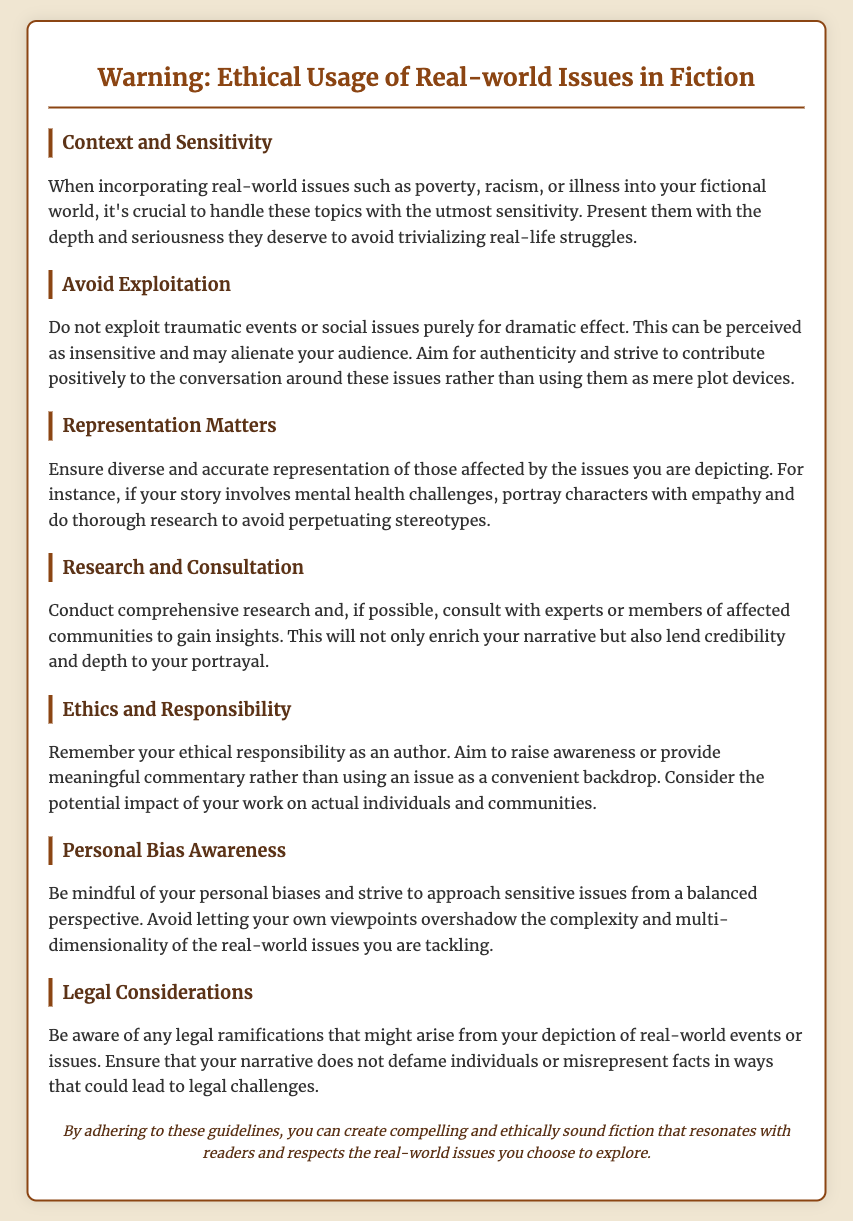What is the title of the document? The title is prominently displayed at the top of the document, summarizing its purpose regarding ethical usage in fiction.
Answer: Warning: Ethical Usage of Real-world Issues in Fiction How many sections are in the document? The document is divided into 6 sections, each presenting different aspects related to the ethical usage of real-world issues in fiction.
Answer: 6 What is one of the key themes discussed in the document? The document outlines several key themes, one of which emphasizes the importance of treating real-world issues with care and sensitivity.
Answer: Context and Sensitivity What should authors avoid exploiting, according to the guidelines? The document advises against exploiting sensitive subjects that could cause real emotional harm to individuals or groups for mere dramatic purposes.
Answer: Traumatic events or social issues What should authors conduct for their narratives? The document specifically suggests that authors should engage in thorough background work to ensure the authenticity of their stories.
Answer: Research and Consultation What is a personal attribute authors should be aware of when writing about sensitive issues? The document mentions that authors need to remain conscious of their own perspectives and ensure they do not skew the representation of complex issues.
Answer: Personal Bias Awareness What is the implied responsibility of authors when incorporating real-world issues? The document suggests that as authors, one should not only tell stories but also strive to provide deeper insights or commentary on the issues raised.
Answer: Ethics and Responsibility What is a potential risk of misrepresenting real-world events in fiction? The document highlights legal challenges as a significant concern if authors mischaracterize events or individuals in their narratives.
Answer: Legal considerations 